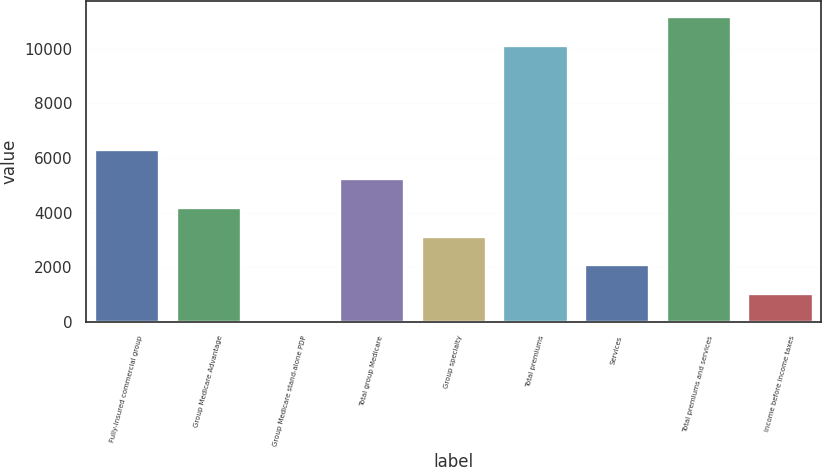Convert chart to OTSL. <chart><loc_0><loc_0><loc_500><loc_500><bar_chart><fcel>Fully-insured commercial group<fcel>Group Medicare Advantage<fcel>Group Medicare stand-alone PDP<fcel>Total group Medicare<fcel>Group specialty<fcel>Total premiums<fcel>Services<fcel>Total premiums and services<fcel>Income before income taxes<nl><fcel>6308<fcel>4208<fcel>8<fcel>5258<fcel>3158<fcel>10138<fcel>2108<fcel>11188<fcel>1058<nl></chart> 